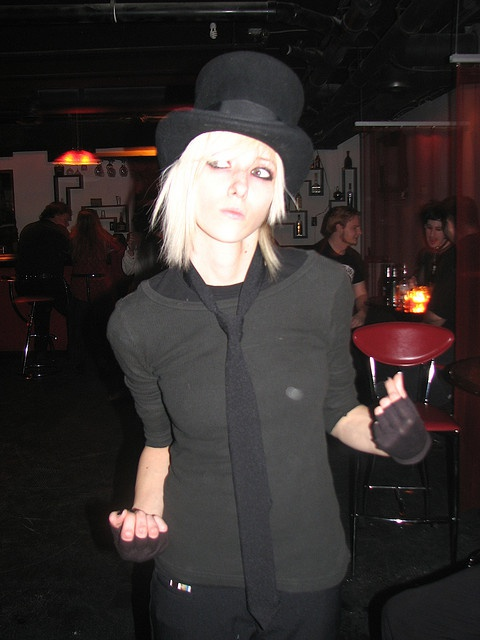Describe the objects in this image and their specific colors. I can see people in black, gray, white, and tan tones, chair in black, maroon, and brown tones, tie in black tones, people in black, maroon, and gray tones, and people in black, maroon, and brown tones in this image. 